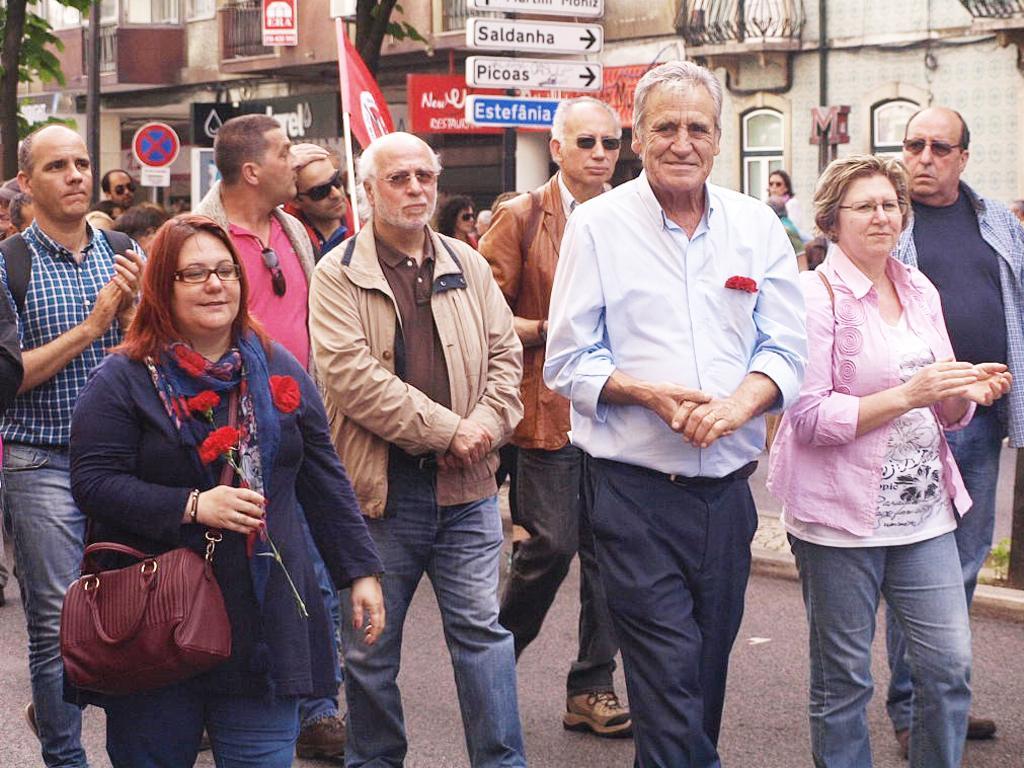Could you give a brief overview of what you see in this image? Here we can see that a group of people walking on the road ,and here is the building, and here is the tree, and her is the flag. 